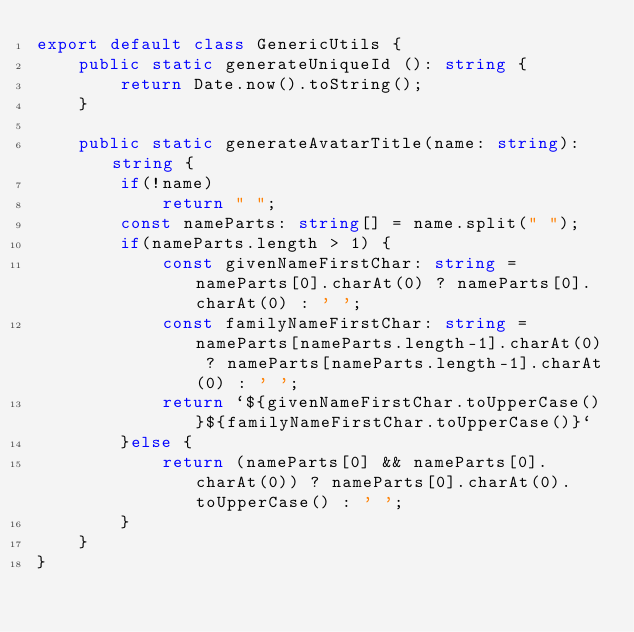<code> <loc_0><loc_0><loc_500><loc_500><_TypeScript_>export default class GenericUtils {
    public static generateUniqueId (): string {
        return Date.now().toString();
    }

    public static generateAvatarTitle(name: string): string {
        if(!name)
            return " ";
        const nameParts: string[] = name.split(" ");
        if(nameParts.length > 1) {
            const givenNameFirstChar: string = nameParts[0].charAt(0) ? nameParts[0].charAt(0) : ' ';
            const familyNameFirstChar: string = nameParts[nameParts.length-1].charAt(0) ? nameParts[nameParts.length-1].charAt(0) : ' ';
            return `${givenNameFirstChar.toUpperCase()}${familyNameFirstChar.toUpperCase()}`
        }else {
            return (nameParts[0] && nameParts[0].charAt(0)) ? nameParts[0].charAt(0).toUpperCase() : ' ';
        }
    }
}</code> 